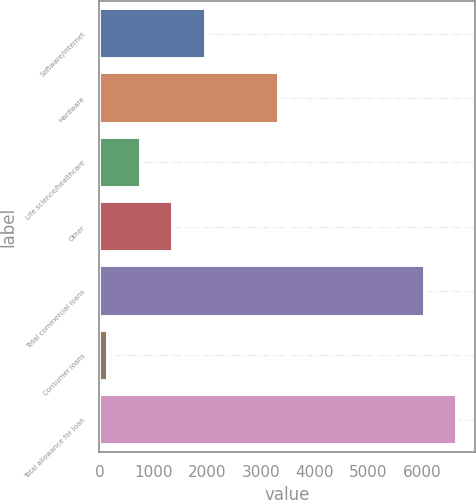Convert chart to OTSL. <chart><loc_0><loc_0><loc_500><loc_500><bar_chart><fcel>Software/internet<fcel>Hardware<fcel>Life science/healthcare<fcel>Other<fcel>Total commercial loans<fcel>Consumer loans<fcel>Total allowance for loan<nl><fcel>1976.8<fcel>3332<fcel>767.6<fcel>1372.2<fcel>6046<fcel>163<fcel>6650.6<nl></chart> 